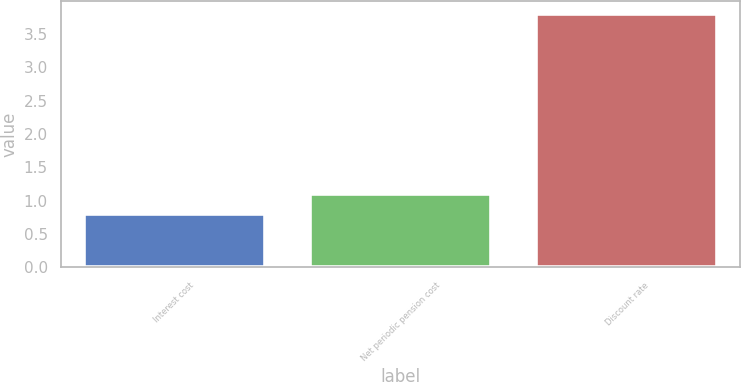Convert chart. <chart><loc_0><loc_0><loc_500><loc_500><bar_chart><fcel>Interest cost<fcel>Net periodic pension cost<fcel>Discount rate<nl><fcel>0.8<fcel>1.1<fcel>3.8<nl></chart> 